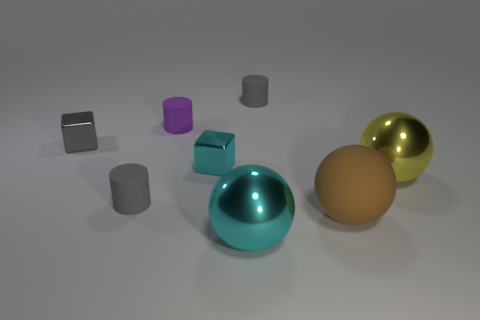What materials do the objects in the image appear to be made of? The objects in the image seem to be rendered with different textures and finishes suggesting various materials. The balls have a shiny, rubber-like quality to them, one in teal, one in gold, and one in an earthy matte finish. The cylinders and cube seem metallic due to their reflective surfaces; one cylinder and the cube in particular possess a chrome-like appearance, while the gray cylinders have a satin finish, indicating a possible metallic but less reflective quality. 